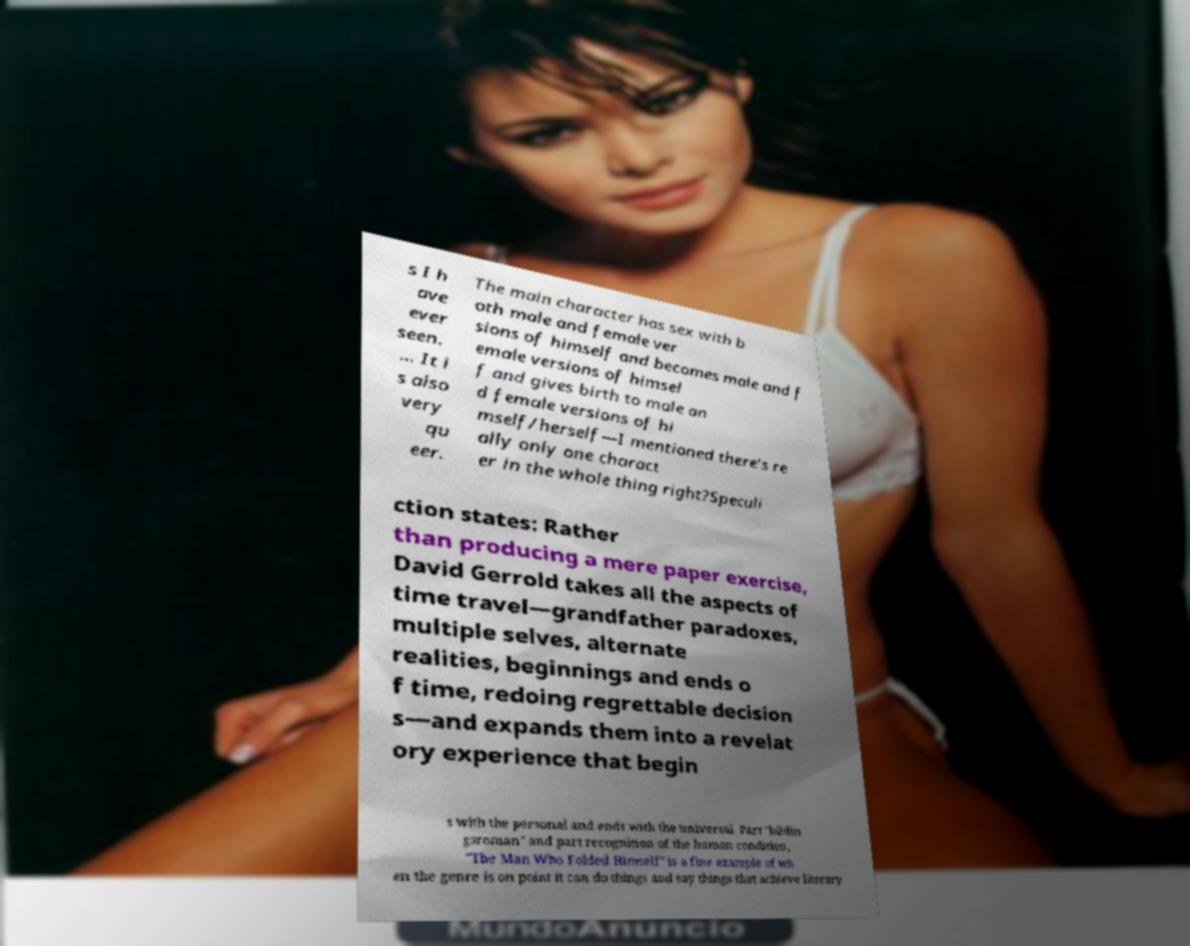Please read and relay the text visible in this image. What does it say? s I h ave ever seen. ... It i s also very qu eer. The main character has sex with b oth male and female ver sions of himself and becomes male and f emale versions of himsel f and gives birth to male an d female versions of hi mself/herself—I mentioned there’s re ally only one charact er in the whole thing right?Speculi ction states: Rather than producing a mere paper exercise, David Gerrold takes all the aspects of time travel—grandfather paradoxes, multiple selves, alternate realities, beginnings and ends o f time, redoing regrettable decision s—and expands them into a revelat ory experience that begin s with the personal and ends with the universal. Part "bildin gsroman" and part recognition of the human condition, "The Man Who Folded Himself" is a fine example of wh en the genre is on point it can do things and say things that achieve literary 